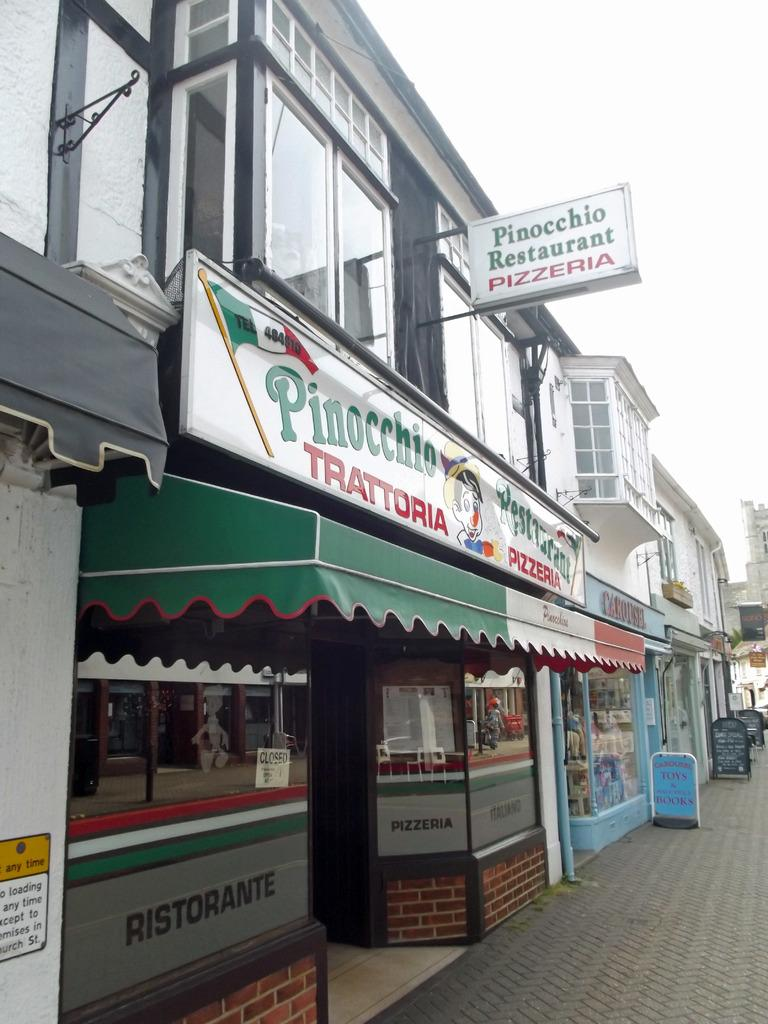<image>
Create a compact narrative representing the image presented. A Pizzeria has an awning in the colors of the Italian flag. 